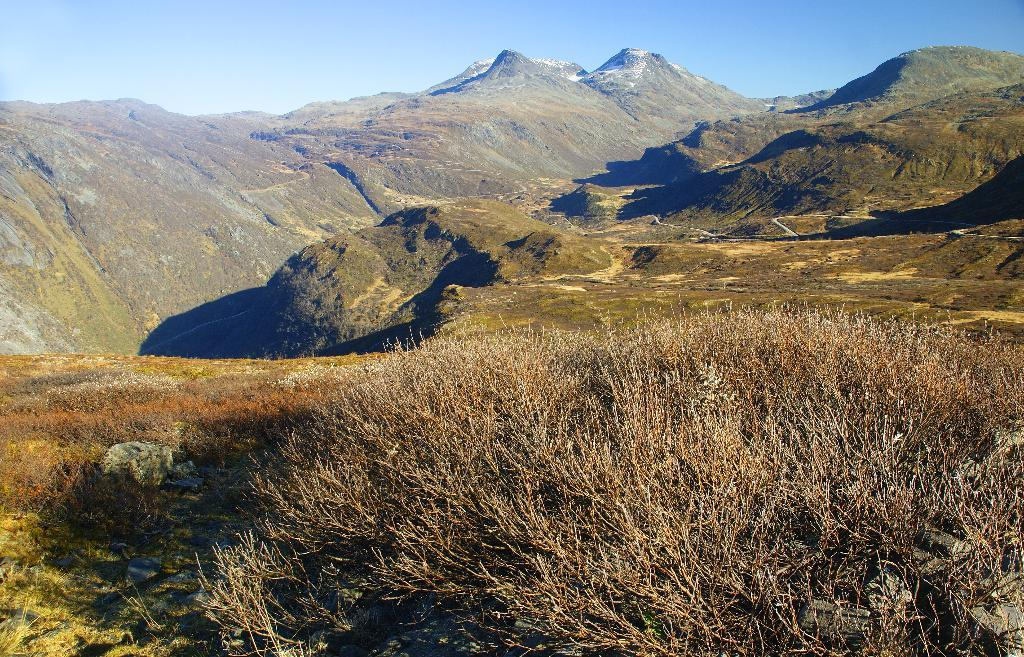What type of natural formation can be seen in the image? There are mountains in the image. What other elements are present in the image besides the mountains? There are plants in the image. What type of chess piece is depicted among the plants in the image? There is no chess piece present in the image; it only features mountains and plants. 